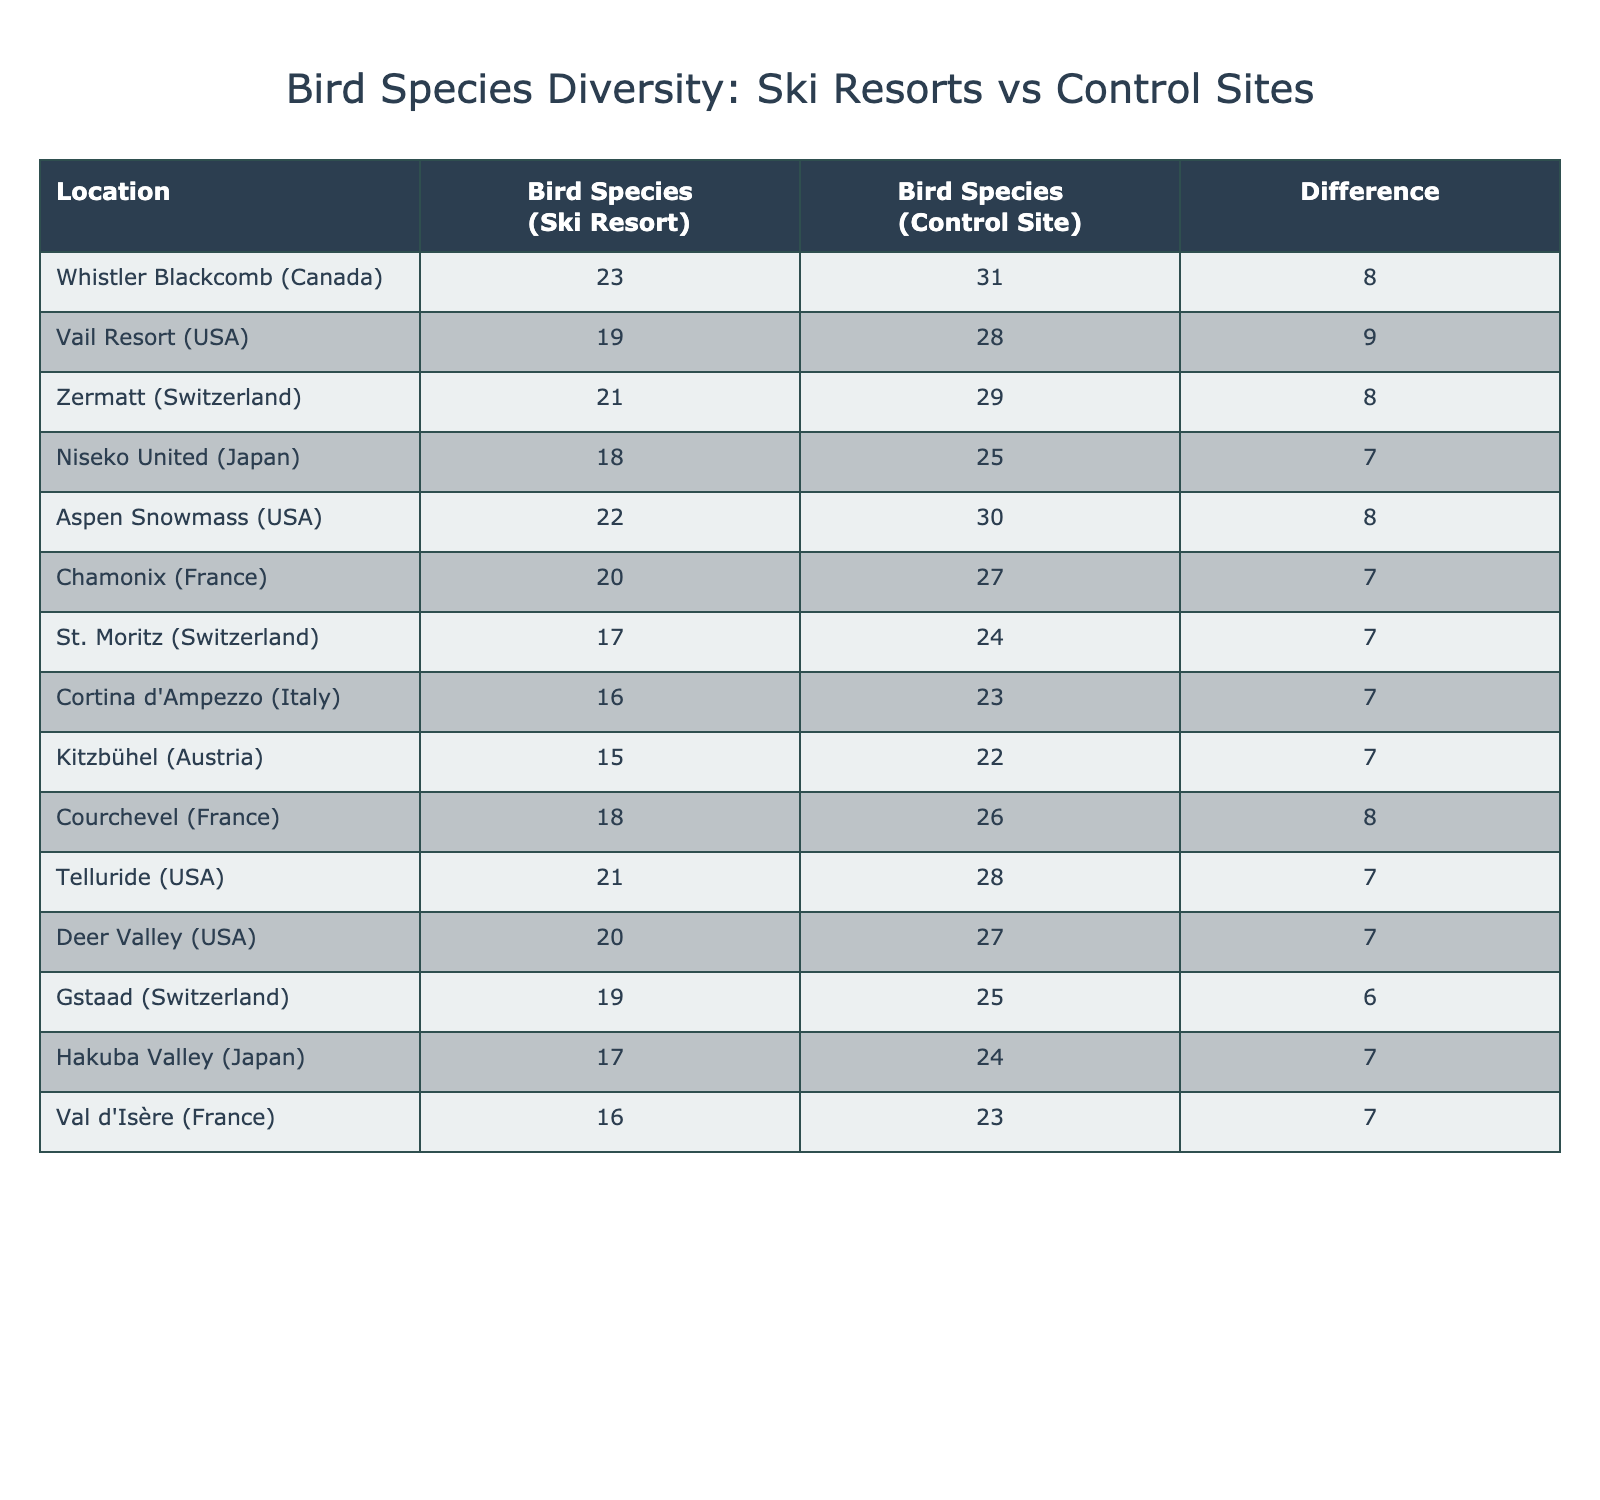What is the bird species count at Whistler Blackcomb? The table shows that the bird species count at Whistler Blackcomb (Ski Resort) is 23.
Answer: 23 What is the difference in bird species count between the ski resort and control site at Vail Resort? The table indicates that the bird species count at Vail Resort (Control Site) is 28 and at the Ski Resort is 19. The difference is 28 - 19 = 9.
Answer: 9 Which location has the highest bird species count at the control site? By checking the values in the control site column, it is evident that Whistler Blackcomb has the highest count at 31.
Answer: Whistler Blackcomb Is the bird species count at Aspen Snowmass greater than 20? The count at Aspen Snowmass (Ski Resort) is 22, which is indeed greater than 20.
Answer: Yes Calculate the average bird species count for ski resorts. Adding all ski resort counts: 23 + 19 + 21 + 18 + 22 + 20 + 17 + 16 + 15 + 18 + 21 + 20 + 19 + 17 + 16 =  19. The number of locations is 15, so the average is 19/15 ≈ 19.
Answer: 19 What is the total difference in bird species counts between ski resorts and control sites for all locations? The differences can be calculated as follows: (31 - 23) + (28 - 19) + (29 - 21) + (25 - 18) + (30 - 22) + (27 - 20) + (24 - 17) + (23 - 16) + (22 - 15) + (26 - 18) + (28 - 21) + (27 - 20) + (25 - 19) + (24 - 17) + (23 - 16) = 16.
Answer: 16 How many more bird species are found at the control site than at the ski resort in Chamonix? The control site at Chamonix has 27 species while the ski resort has 20, so the difference is 27 - 20 = 7.
Answer: 7 Which ski resort location has the closest count to its corresponding control site? By examining the differences, Niseko United has the closest count with a difference of 7 (25 - 18).
Answer: Niseko United What is the total bird species count (both ski resort and control site) at Kitzbühel? The table shows Kitzbühel has 15 species at the ski resort and 22 at the control site, totaling 15 + 22 = 37.
Answer: 37 Is there a location where the control site count is less than the ski resort count? By reviewing the counts, all control site counts are equal or greater than ski resort counts, so the answer is no.
Answer: No 